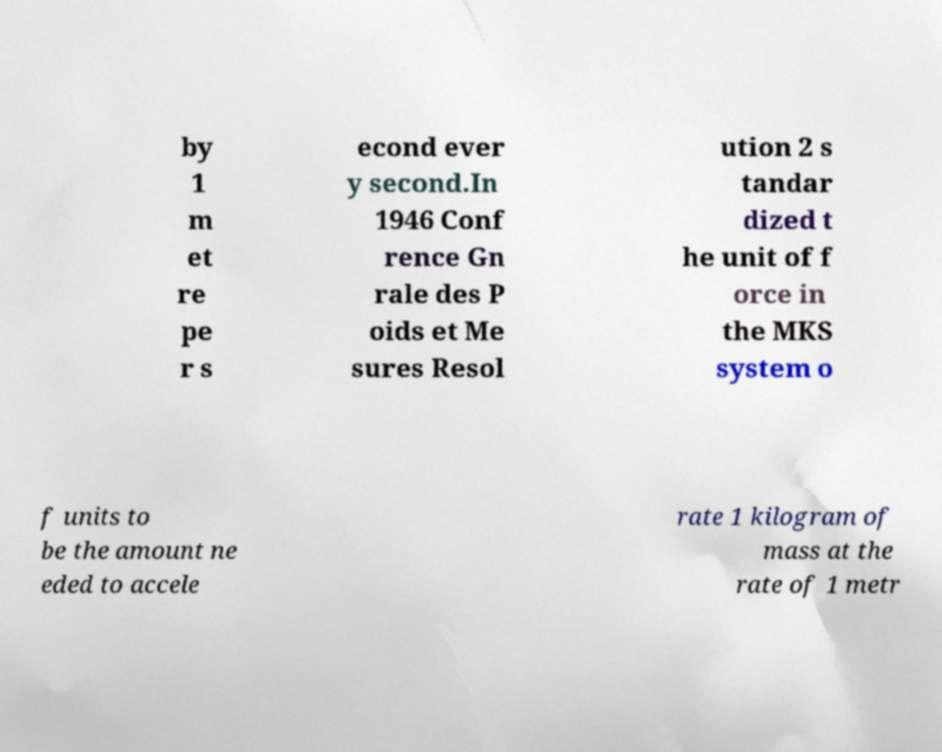Can you accurately transcribe the text from the provided image for me? by 1 m et re pe r s econd ever y second.In 1946 Conf rence Gn rale des P oids et Me sures Resol ution 2 s tandar dized t he unit of f orce in the MKS system o f units to be the amount ne eded to accele rate 1 kilogram of mass at the rate of 1 metr 